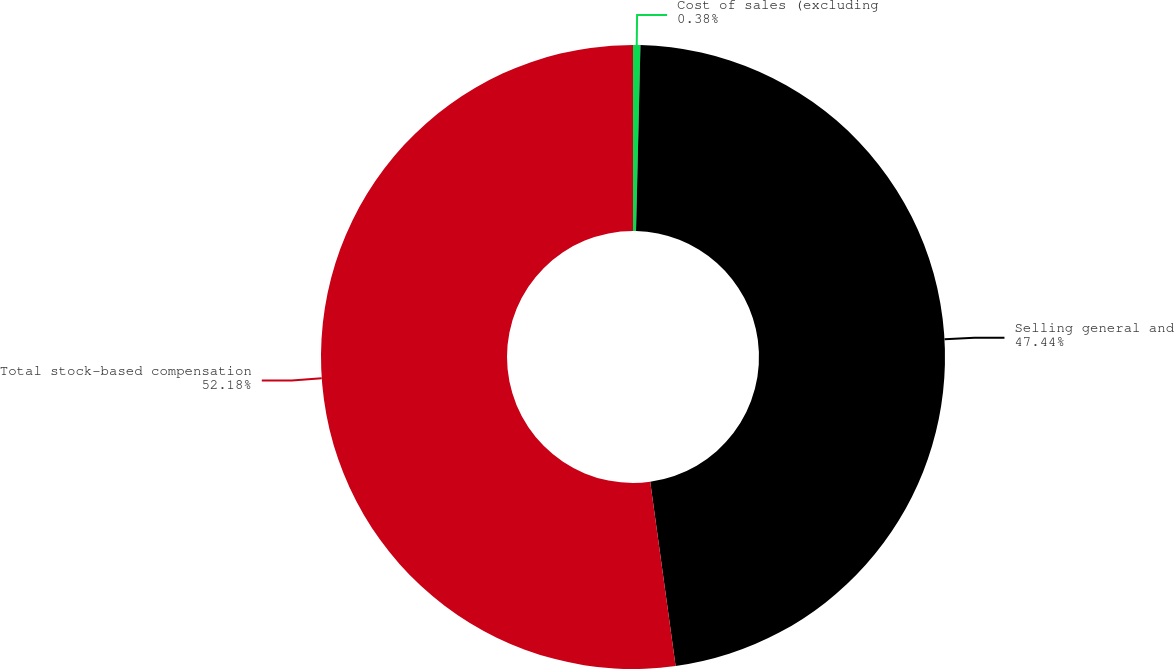Convert chart. <chart><loc_0><loc_0><loc_500><loc_500><pie_chart><fcel>Cost of sales (excluding<fcel>Selling general and<fcel>Total stock-based compensation<nl><fcel>0.38%<fcel>47.44%<fcel>52.18%<nl></chart> 